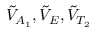Convert formula to latex. <formula><loc_0><loc_0><loc_500><loc_500>\tilde { V } _ { A _ { 1 } } , \tilde { V } _ { E } , \tilde { V } _ { T _ { 2 } }</formula> 